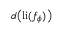Convert formula to latex. <formula><loc_0><loc_0><loc_500><loc_500>d \left ( l i ( f _ { \phi } ) \right )</formula> 